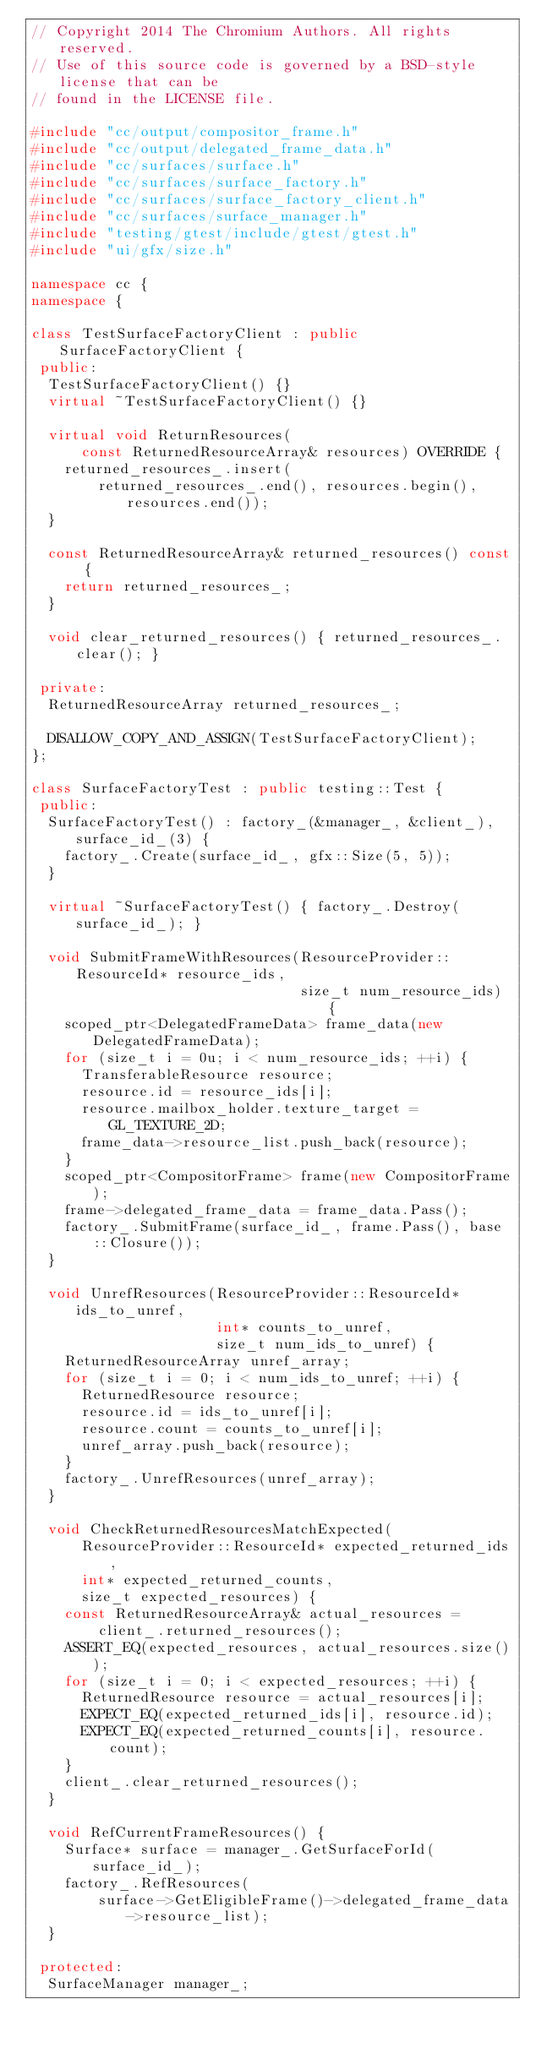Convert code to text. <code><loc_0><loc_0><loc_500><loc_500><_C++_>// Copyright 2014 The Chromium Authors. All rights reserved.
// Use of this source code is governed by a BSD-style license that can be
// found in the LICENSE file.

#include "cc/output/compositor_frame.h"
#include "cc/output/delegated_frame_data.h"
#include "cc/surfaces/surface.h"
#include "cc/surfaces/surface_factory.h"
#include "cc/surfaces/surface_factory_client.h"
#include "cc/surfaces/surface_manager.h"
#include "testing/gtest/include/gtest/gtest.h"
#include "ui/gfx/size.h"

namespace cc {
namespace {

class TestSurfaceFactoryClient : public SurfaceFactoryClient {
 public:
  TestSurfaceFactoryClient() {}
  virtual ~TestSurfaceFactoryClient() {}

  virtual void ReturnResources(
      const ReturnedResourceArray& resources) OVERRIDE {
    returned_resources_.insert(
        returned_resources_.end(), resources.begin(), resources.end());
  }

  const ReturnedResourceArray& returned_resources() const {
    return returned_resources_;
  }

  void clear_returned_resources() { returned_resources_.clear(); }

 private:
  ReturnedResourceArray returned_resources_;

  DISALLOW_COPY_AND_ASSIGN(TestSurfaceFactoryClient);
};

class SurfaceFactoryTest : public testing::Test {
 public:
  SurfaceFactoryTest() : factory_(&manager_, &client_), surface_id_(3) {
    factory_.Create(surface_id_, gfx::Size(5, 5));
  }

  virtual ~SurfaceFactoryTest() { factory_.Destroy(surface_id_); }

  void SubmitFrameWithResources(ResourceProvider::ResourceId* resource_ids,
                                size_t num_resource_ids) {
    scoped_ptr<DelegatedFrameData> frame_data(new DelegatedFrameData);
    for (size_t i = 0u; i < num_resource_ids; ++i) {
      TransferableResource resource;
      resource.id = resource_ids[i];
      resource.mailbox_holder.texture_target = GL_TEXTURE_2D;
      frame_data->resource_list.push_back(resource);
    }
    scoped_ptr<CompositorFrame> frame(new CompositorFrame);
    frame->delegated_frame_data = frame_data.Pass();
    factory_.SubmitFrame(surface_id_, frame.Pass(), base::Closure());
  }

  void UnrefResources(ResourceProvider::ResourceId* ids_to_unref,
                      int* counts_to_unref,
                      size_t num_ids_to_unref) {
    ReturnedResourceArray unref_array;
    for (size_t i = 0; i < num_ids_to_unref; ++i) {
      ReturnedResource resource;
      resource.id = ids_to_unref[i];
      resource.count = counts_to_unref[i];
      unref_array.push_back(resource);
    }
    factory_.UnrefResources(unref_array);
  }

  void CheckReturnedResourcesMatchExpected(
      ResourceProvider::ResourceId* expected_returned_ids,
      int* expected_returned_counts,
      size_t expected_resources) {
    const ReturnedResourceArray& actual_resources =
        client_.returned_resources();
    ASSERT_EQ(expected_resources, actual_resources.size());
    for (size_t i = 0; i < expected_resources; ++i) {
      ReturnedResource resource = actual_resources[i];
      EXPECT_EQ(expected_returned_ids[i], resource.id);
      EXPECT_EQ(expected_returned_counts[i], resource.count);
    }
    client_.clear_returned_resources();
  }

  void RefCurrentFrameResources() {
    Surface* surface = manager_.GetSurfaceForId(surface_id_);
    factory_.RefResources(
        surface->GetEligibleFrame()->delegated_frame_data->resource_list);
  }

 protected:
  SurfaceManager manager_;</code> 